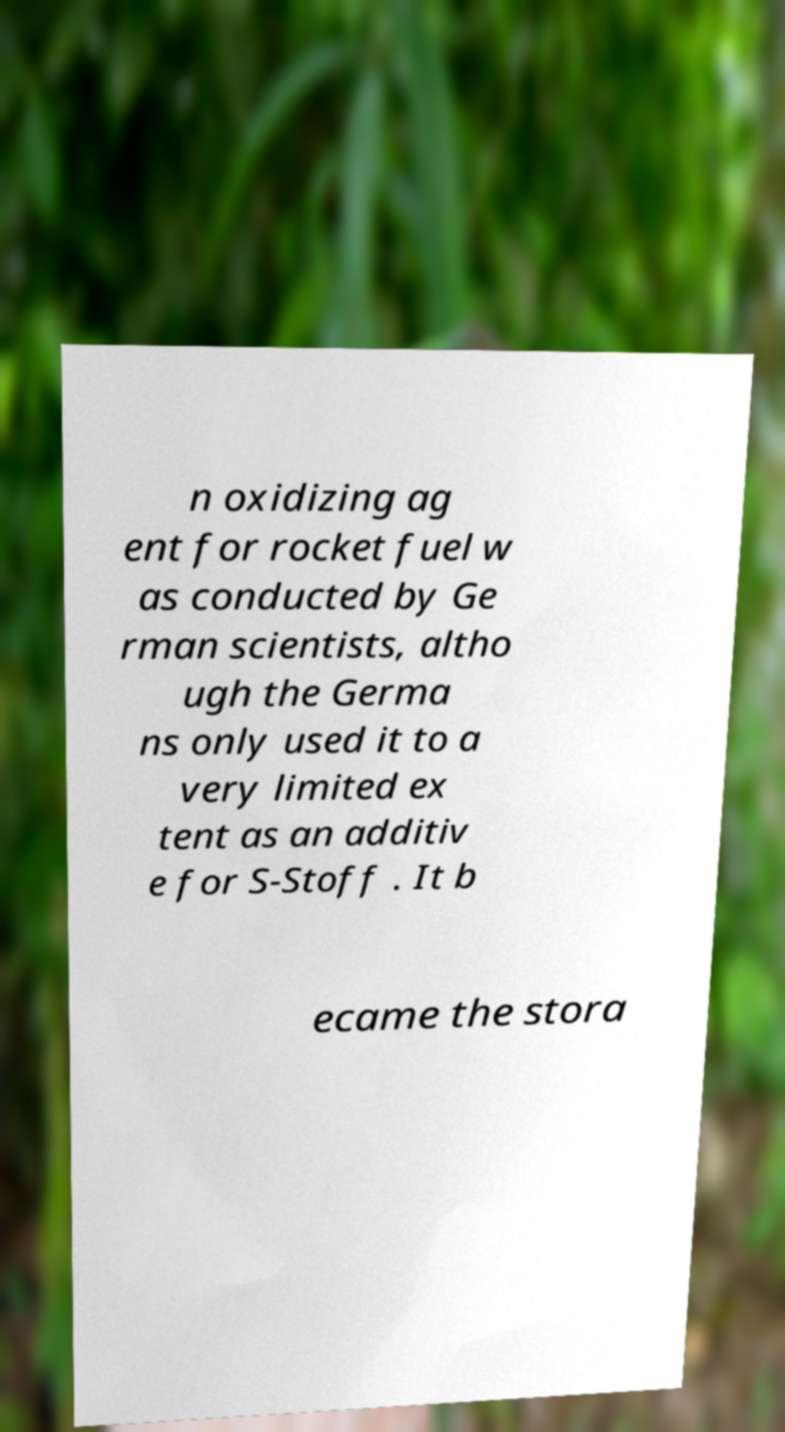Can you read and provide the text displayed in the image?This photo seems to have some interesting text. Can you extract and type it out for me? n oxidizing ag ent for rocket fuel w as conducted by Ge rman scientists, altho ugh the Germa ns only used it to a very limited ex tent as an additiv e for S-Stoff . It b ecame the stora 